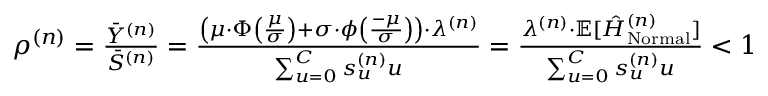<formula> <loc_0><loc_0><loc_500><loc_500>\begin{array} { r } { \rho ^ { ( n ) } = \frac { \ B a r { Y } ^ { ( n ) } } { \ B a r { S } ^ { ( n ) } } = \frac { \left ( \mu \cdot \Phi \left ( \frac { \mu } { \sigma } \right ) + \sigma \cdot \phi \left ( \frac { - \mu } { \sigma } \right ) \right ) \cdot \lambda ^ { ( n ) } } { \sum _ { u = 0 } ^ { C } s _ { u } ^ { ( n ) } u } = \frac { \lambda ^ { ( n ) } \cdot \mathbb { E } [ \hat { H } _ { N o r m a l } ^ { ( n ) } ] } { \sum _ { u = 0 } ^ { C } s _ { u } ^ { ( n ) } u } < 1 } \end{array}</formula> 